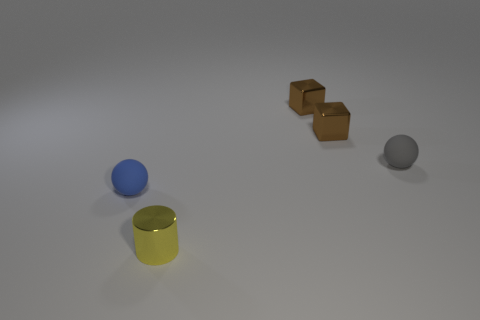What color is the other small matte object that is the same shape as the gray rubber thing?
Give a very brief answer. Blue. How many small things are there?
Your response must be concise. 5. Does the small sphere that is on the left side of the small yellow shiny thing have the same material as the tiny yellow object?
Make the answer very short. No. Are there any other things that are made of the same material as the cylinder?
Offer a terse response. Yes. There is a matte thing to the left of the sphere that is behind the blue ball; how many blue rubber objects are to the left of it?
Your answer should be very brief. 0. The blue thing has what size?
Provide a succinct answer. Small. What is the size of the gray rubber ball right of the tiny yellow shiny object?
Offer a terse response. Small. How many other objects are the same shape as the gray rubber thing?
Offer a terse response. 1. Are there an equal number of blue matte things on the left side of the small blue sphere and small yellow cylinders that are on the left side of the yellow object?
Give a very brief answer. Yes. Are the tiny ball that is to the left of the metal cylinder and the tiny thing in front of the small blue thing made of the same material?
Give a very brief answer. No. 